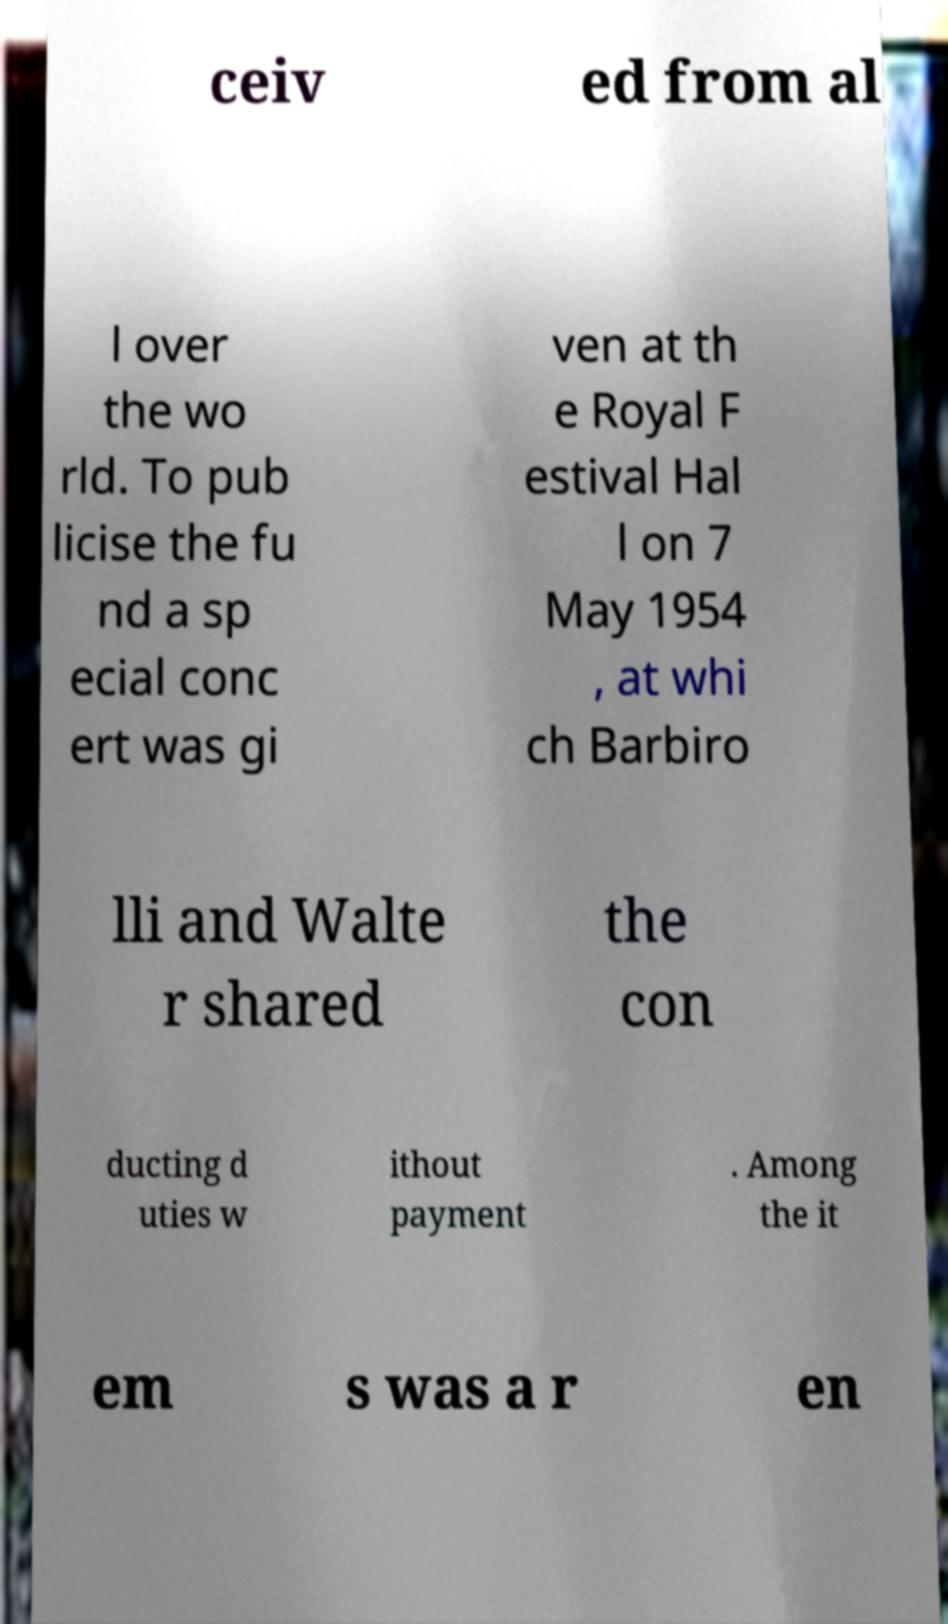What messages or text are displayed in this image? I need them in a readable, typed format. ceiv ed from al l over the wo rld. To pub licise the fu nd a sp ecial conc ert was gi ven at th e Royal F estival Hal l on 7 May 1954 , at whi ch Barbiro lli and Walte r shared the con ducting d uties w ithout payment . Among the it em s was a r en 